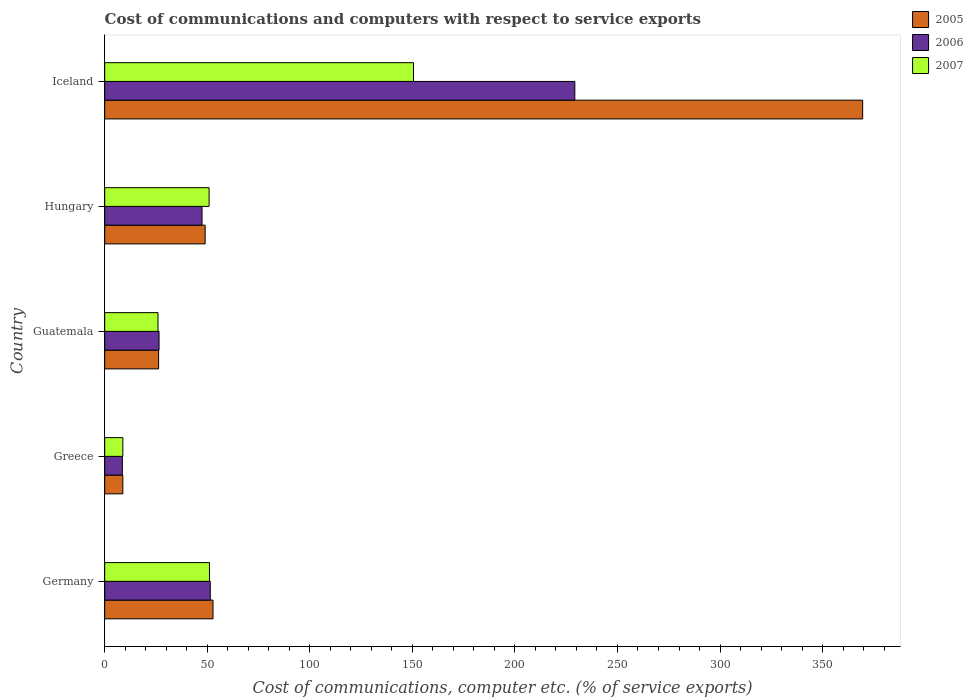How many different coloured bars are there?
Provide a succinct answer. 3. Are the number of bars per tick equal to the number of legend labels?
Offer a terse response. Yes. How many bars are there on the 3rd tick from the top?
Provide a succinct answer. 3. What is the cost of communications and computers in 2007 in Iceland?
Ensure brevity in your answer.  150.55. Across all countries, what is the maximum cost of communications and computers in 2007?
Your answer should be compact. 150.55. Across all countries, what is the minimum cost of communications and computers in 2005?
Your answer should be compact. 8.84. What is the total cost of communications and computers in 2007 in the graph?
Give a very brief answer. 287.32. What is the difference between the cost of communications and computers in 2005 in Greece and that in Iceland?
Offer a terse response. -360.7. What is the difference between the cost of communications and computers in 2006 in Guatemala and the cost of communications and computers in 2005 in Germany?
Keep it short and to the point. -26.32. What is the average cost of communications and computers in 2006 per country?
Keep it short and to the point. 72.64. What is the difference between the cost of communications and computers in 2007 and cost of communications and computers in 2006 in Iceland?
Provide a succinct answer. -78.66. In how many countries, is the cost of communications and computers in 2006 greater than 30 %?
Keep it short and to the point. 3. What is the ratio of the cost of communications and computers in 2005 in Greece to that in Guatemala?
Your response must be concise. 0.34. What is the difference between the highest and the second highest cost of communications and computers in 2007?
Provide a short and direct response. 99.49. What is the difference between the highest and the lowest cost of communications and computers in 2006?
Keep it short and to the point. 220.61. Is the sum of the cost of communications and computers in 2007 in Germany and Hungary greater than the maximum cost of communications and computers in 2006 across all countries?
Keep it short and to the point. No. What does the 1st bar from the bottom in Hungary represents?
Your answer should be very brief. 2005. How many countries are there in the graph?
Give a very brief answer. 5. What is the difference between two consecutive major ticks on the X-axis?
Make the answer very short. 50. Are the values on the major ticks of X-axis written in scientific E-notation?
Offer a terse response. No. Does the graph contain any zero values?
Provide a short and direct response. No. Does the graph contain grids?
Your answer should be compact. No. Where does the legend appear in the graph?
Your answer should be compact. Top right. How many legend labels are there?
Give a very brief answer. 3. How are the legend labels stacked?
Keep it short and to the point. Vertical. What is the title of the graph?
Your answer should be compact. Cost of communications and computers with respect to service exports. What is the label or title of the X-axis?
Provide a short and direct response. Cost of communications, computer etc. (% of service exports). What is the Cost of communications, computer etc. (% of service exports) of 2005 in Germany?
Offer a very short reply. 52.8. What is the Cost of communications, computer etc. (% of service exports) of 2006 in Germany?
Make the answer very short. 51.47. What is the Cost of communications, computer etc. (% of service exports) of 2007 in Germany?
Your answer should be very brief. 51.06. What is the Cost of communications, computer etc. (% of service exports) in 2005 in Greece?
Your answer should be compact. 8.84. What is the Cost of communications, computer etc. (% of service exports) of 2006 in Greece?
Ensure brevity in your answer.  8.6. What is the Cost of communications, computer etc. (% of service exports) of 2007 in Greece?
Offer a terse response. 8.84. What is the Cost of communications, computer etc. (% of service exports) in 2005 in Guatemala?
Your response must be concise. 26.27. What is the Cost of communications, computer etc. (% of service exports) in 2006 in Guatemala?
Provide a short and direct response. 26.49. What is the Cost of communications, computer etc. (% of service exports) of 2007 in Guatemala?
Keep it short and to the point. 25.98. What is the Cost of communications, computer etc. (% of service exports) in 2005 in Hungary?
Your answer should be compact. 48.97. What is the Cost of communications, computer etc. (% of service exports) in 2006 in Hungary?
Ensure brevity in your answer.  47.45. What is the Cost of communications, computer etc. (% of service exports) in 2007 in Hungary?
Your response must be concise. 50.89. What is the Cost of communications, computer etc. (% of service exports) of 2005 in Iceland?
Provide a succinct answer. 369.54. What is the Cost of communications, computer etc. (% of service exports) of 2006 in Iceland?
Provide a succinct answer. 229.21. What is the Cost of communications, computer etc. (% of service exports) in 2007 in Iceland?
Offer a terse response. 150.55. Across all countries, what is the maximum Cost of communications, computer etc. (% of service exports) of 2005?
Offer a very short reply. 369.54. Across all countries, what is the maximum Cost of communications, computer etc. (% of service exports) in 2006?
Your response must be concise. 229.21. Across all countries, what is the maximum Cost of communications, computer etc. (% of service exports) in 2007?
Give a very brief answer. 150.55. Across all countries, what is the minimum Cost of communications, computer etc. (% of service exports) of 2005?
Provide a short and direct response. 8.84. Across all countries, what is the minimum Cost of communications, computer etc. (% of service exports) in 2006?
Give a very brief answer. 8.6. Across all countries, what is the minimum Cost of communications, computer etc. (% of service exports) of 2007?
Give a very brief answer. 8.84. What is the total Cost of communications, computer etc. (% of service exports) of 2005 in the graph?
Offer a terse response. 506.42. What is the total Cost of communications, computer etc. (% of service exports) of 2006 in the graph?
Your answer should be very brief. 363.22. What is the total Cost of communications, computer etc. (% of service exports) in 2007 in the graph?
Provide a short and direct response. 287.32. What is the difference between the Cost of communications, computer etc. (% of service exports) of 2005 in Germany and that in Greece?
Offer a very short reply. 43.96. What is the difference between the Cost of communications, computer etc. (% of service exports) in 2006 in Germany and that in Greece?
Make the answer very short. 42.87. What is the difference between the Cost of communications, computer etc. (% of service exports) in 2007 in Germany and that in Greece?
Ensure brevity in your answer.  42.22. What is the difference between the Cost of communications, computer etc. (% of service exports) of 2005 in Germany and that in Guatemala?
Your answer should be compact. 26.54. What is the difference between the Cost of communications, computer etc. (% of service exports) of 2006 in Germany and that in Guatemala?
Your answer should be compact. 24.98. What is the difference between the Cost of communications, computer etc. (% of service exports) in 2007 in Germany and that in Guatemala?
Offer a very short reply. 25.09. What is the difference between the Cost of communications, computer etc. (% of service exports) in 2005 in Germany and that in Hungary?
Give a very brief answer. 3.84. What is the difference between the Cost of communications, computer etc. (% of service exports) of 2006 in Germany and that in Hungary?
Provide a short and direct response. 4.01. What is the difference between the Cost of communications, computer etc. (% of service exports) in 2007 in Germany and that in Hungary?
Give a very brief answer. 0.17. What is the difference between the Cost of communications, computer etc. (% of service exports) in 2005 in Germany and that in Iceland?
Your answer should be compact. -316.74. What is the difference between the Cost of communications, computer etc. (% of service exports) in 2006 in Germany and that in Iceland?
Ensure brevity in your answer.  -177.74. What is the difference between the Cost of communications, computer etc. (% of service exports) in 2007 in Germany and that in Iceland?
Provide a succinct answer. -99.49. What is the difference between the Cost of communications, computer etc. (% of service exports) of 2005 in Greece and that in Guatemala?
Offer a very short reply. -17.42. What is the difference between the Cost of communications, computer etc. (% of service exports) of 2006 in Greece and that in Guatemala?
Keep it short and to the point. -17.89. What is the difference between the Cost of communications, computer etc. (% of service exports) in 2007 in Greece and that in Guatemala?
Give a very brief answer. -17.13. What is the difference between the Cost of communications, computer etc. (% of service exports) in 2005 in Greece and that in Hungary?
Offer a very short reply. -40.13. What is the difference between the Cost of communications, computer etc. (% of service exports) of 2006 in Greece and that in Hungary?
Keep it short and to the point. -38.86. What is the difference between the Cost of communications, computer etc. (% of service exports) in 2007 in Greece and that in Hungary?
Keep it short and to the point. -42.05. What is the difference between the Cost of communications, computer etc. (% of service exports) of 2005 in Greece and that in Iceland?
Make the answer very short. -360.7. What is the difference between the Cost of communications, computer etc. (% of service exports) in 2006 in Greece and that in Iceland?
Your response must be concise. -220.61. What is the difference between the Cost of communications, computer etc. (% of service exports) of 2007 in Greece and that in Iceland?
Ensure brevity in your answer.  -141.71. What is the difference between the Cost of communications, computer etc. (% of service exports) of 2005 in Guatemala and that in Hungary?
Provide a short and direct response. -22.7. What is the difference between the Cost of communications, computer etc. (% of service exports) of 2006 in Guatemala and that in Hungary?
Offer a very short reply. -20.97. What is the difference between the Cost of communications, computer etc. (% of service exports) in 2007 in Guatemala and that in Hungary?
Your answer should be very brief. -24.91. What is the difference between the Cost of communications, computer etc. (% of service exports) of 2005 in Guatemala and that in Iceland?
Offer a terse response. -343.28. What is the difference between the Cost of communications, computer etc. (% of service exports) of 2006 in Guatemala and that in Iceland?
Make the answer very short. -202.72. What is the difference between the Cost of communications, computer etc. (% of service exports) of 2007 in Guatemala and that in Iceland?
Offer a very short reply. -124.58. What is the difference between the Cost of communications, computer etc. (% of service exports) of 2005 in Hungary and that in Iceland?
Make the answer very short. -320.58. What is the difference between the Cost of communications, computer etc. (% of service exports) of 2006 in Hungary and that in Iceland?
Your answer should be compact. -181.76. What is the difference between the Cost of communications, computer etc. (% of service exports) of 2007 in Hungary and that in Iceland?
Provide a succinct answer. -99.66. What is the difference between the Cost of communications, computer etc. (% of service exports) in 2005 in Germany and the Cost of communications, computer etc. (% of service exports) in 2006 in Greece?
Give a very brief answer. 44.2. What is the difference between the Cost of communications, computer etc. (% of service exports) of 2005 in Germany and the Cost of communications, computer etc. (% of service exports) of 2007 in Greece?
Provide a succinct answer. 43.96. What is the difference between the Cost of communications, computer etc. (% of service exports) in 2006 in Germany and the Cost of communications, computer etc. (% of service exports) in 2007 in Greece?
Give a very brief answer. 42.63. What is the difference between the Cost of communications, computer etc. (% of service exports) of 2005 in Germany and the Cost of communications, computer etc. (% of service exports) of 2006 in Guatemala?
Provide a succinct answer. 26.32. What is the difference between the Cost of communications, computer etc. (% of service exports) in 2005 in Germany and the Cost of communications, computer etc. (% of service exports) in 2007 in Guatemala?
Ensure brevity in your answer.  26.83. What is the difference between the Cost of communications, computer etc. (% of service exports) of 2006 in Germany and the Cost of communications, computer etc. (% of service exports) of 2007 in Guatemala?
Make the answer very short. 25.49. What is the difference between the Cost of communications, computer etc. (% of service exports) of 2005 in Germany and the Cost of communications, computer etc. (% of service exports) of 2006 in Hungary?
Keep it short and to the point. 5.35. What is the difference between the Cost of communications, computer etc. (% of service exports) of 2005 in Germany and the Cost of communications, computer etc. (% of service exports) of 2007 in Hungary?
Give a very brief answer. 1.91. What is the difference between the Cost of communications, computer etc. (% of service exports) of 2006 in Germany and the Cost of communications, computer etc. (% of service exports) of 2007 in Hungary?
Provide a short and direct response. 0.58. What is the difference between the Cost of communications, computer etc. (% of service exports) in 2005 in Germany and the Cost of communications, computer etc. (% of service exports) in 2006 in Iceland?
Give a very brief answer. -176.41. What is the difference between the Cost of communications, computer etc. (% of service exports) in 2005 in Germany and the Cost of communications, computer etc. (% of service exports) in 2007 in Iceland?
Keep it short and to the point. -97.75. What is the difference between the Cost of communications, computer etc. (% of service exports) of 2006 in Germany and the Cost of communications, computer etc. (% of service exports) of 2007 in Iceland?
Ensure brevity in your answer.  -99.09. What is the difference between the Cost of communications, computer etc. (% of service exports) of 2005 in Greece and the Cost of communications, computer etc. (% of service exports) of 2006 in Guatemala?
Give a very brief answer. -17.65. What is the difference between the Cost of communications, computer etc. (% of service exports) in 2005 in Greece and the Cost of communications, computer etc. (% of service exports) in 2007 in Guatemala?
Keep it short and to the point. -17.14. What is the difference between the Cost of communications, computer etc. (% of service exports) of 2006 in Greece and the Cost of communications, computer etc. (% of service exports) of 2007 in Guatemala?
Your answer should be compact. -17.38. What is the difference between the Cost of communications, computer etc. (% of service exports) of 2005 in Greece and the Cost of communications, computer etc. (% of service exports) of 2006 in Hungary?
Provide a succinct answer. -38.61. What is the difference between the Cost of communications, computer etc. (% of service exports) of 2005 in Greece and the Cost of communications, computer etc. (% of service exports) of 2007 in Hungary?
Your answer should be very brief. -42.05. What is the difference between the Cost of communications, computer etc. (% of service exports) in 2006 in Greece and the Cost of communications, computer etc. (% of service exports) in 2007 in Hungary?
Make the answer very short. -42.29. What is the difference between the Cost of communications, computer etc. (% of service exports) of 2005 in Greece and the Cost of communications, computer etc. (% of service exports) of 2006 in Iceland?
Your answer should be very brief. -220.37. What is the difference between the Cost of communications, computer etc. (% of service exports) in 2005 in Greece and the Cost of communications, computer etc. (% of service exports) in 2007 in Iceland?
Your answer should be very brief. -141.71. What is the difference between the Cost of communications, computer etc. (% of service exports) of 2006 in Greece and the Cost of communications, computer etc. (% of service exports) of 2007 in Iceland?
Give a very brief answer. -141.96. What is the difference between the Cost of communications, computer etc. (% of service exports) of 2005 in Guatemala and the Cost of communications, computer etc. (% of service exports) of 2006 in Hungary?
Make the answer very short. -21.19. What is the difference between the Cost of communications, computer etc. (% of service exports) of 2005 in Guatemala and the Cost of communications, computer etc. (% of service exports) of 2007 in Hungary?
Your answer should be very brief. -24.62. What is the difference between the Cost of communications, computer etc. (% of service exports) in 2006 in Guatemala and the Cost of communications, computer etc. (% of service exports) in 2007 in Hungary?
Provide a short and direct response. -24.4. What is the difference between the Cost of communications, computer etc. (% of service exports) in 2005 in Guatemala and the Cost of communications, computer etc. (% of service exports) in 2006 in Iceland?
Provide a succinct answer. -202.95. What is the difference between the Cost of communications, computer etc. (% of service exports) in 2005 in Guatemala and the Cost of communications, computer etc. (% of service exports) in 2007 in Iceland?
Your response must be concise. -124.29. What is the difference between the Cost of communications, computer etc. (% of service exports) of 2006 in Guatemala and the Cost of communications, computer etc. (% of service exports) of 2007 in Iceland?
Keep it short and to the point. -124.07. What is the difference between the Cost of communications, computer etc. (% of service exports) of 2005 in Hungary and the Cost of communications, computer etc. (% of service exports) of 2006 in Iceland?
Your answer should be compact. -180.25. What is the difference between the Cost of communications, computer etc. (% of service exports) in 2005 in Hungary and the Cost of communications, computer etc. (% of service exports) in 2007 in Iceland?
Your answer should be very brief. -101.59. What is the difference between the Cost of communications, computer etc. (% of service exports) of 2006 in Hungary and the Cost of communications, computer etc. (% of service exports) of 2007 in Iceland?
Offer a terse response. -103.1. What is the average Cost of communications, computer etc. (% of service exports) of 2005 per country?
Ensure brevity in your answer.  101.28. What is the average Cost of communications, computer etc. (% of service exports) in 2006 per country?
Offer a terse response. 72.64. What is the average Cost of communications, computer etc. (% of service exports) of 2007 per country?
Ensure brevity in your answer.  57.46. What is the difference between the Cost of communications, computer etc. (% of service exports) in 2005 and Cost of communications, computer etc. (% of service exports) in 2006 in Germany?
Provide a succinct answer. 1.33. What is the difference between the Cost of communications, computer etc. (% of service exports) of 2005 and Cost of communications, computer etc. (% of service exports) of 2007 in Germany?
Offer a very short reply. 1.74. What is the difference between the Cost of communications, computer etc. (% of service exports) of 2006 and Cost of communications, computer etc. (% of service exports) of 2007 in Germany?
Keep it short and to the point. 0.4. What is the difference between the Cost of communications, computer etc. (% of service exports) of 2005 and Cost of communications, computer etc. (% of service exports) of 2006 in Greece?
Provide a succinct answer. 0.24. What is the difference between the Cost of communications, computer etc. (% of service exports) of 2005 and Cost of communications, computer etc. (% of service exports) of 2007 in Greece?
Provide a short and direct response. -0. What is the difference between the Cost of communications, computer etc. (% of service exports) of 2006 and Cost of communications, computer etc. (% of service exports) of 2007 in Greece?
Your answer should be very brief. -0.24. What is the difference between the Cost of communications, computer etc. (% of service exports) of 2005 and Cost of communications, computer etc. (% of service exports) of 2006 in Guatemala?
Your answer should be compact. -0.22. What is the difference between the Cost of communications, computer etc. (% of service exports) of 2005 and Cost of communications, computer etc. (% of service exports) of 2007 in Guatemala?
Ensure brevity in your answer.  0.29. What is the difference between the Cost of communications, computer etc. (% of service exports) of 2006 and Cost of communications, computer etc. (% of service exports) of 2007 in Guatemala?
Your answer should be very brief. 0.51. What is the difference between the Cost of communications, computer etc. (% of service exports) of 2005 and Cost of communications, computer etc. (% of service exports) of 2006 in Hungary?
Your answer should be compact. 1.51. What is the difference between the Cost of communications, computer etc. (% of service exports) of 2005 and Cost of communications, computer etc. (% of service exports) of 2007 in Hungary?
Provide a succinct answer. -1.92. What is the difference between the Cost of communications, computer etc. (% of service exports) of 2006 and Cost of communications, computer etc. (% of service exports) of 2007 in Hungary?
Provide a short and direct response. -3.44. What is the difference between the Cost of communications, computer etc. (% of service exports) of 2005 and Cost of communications, computer etc. (% of service exports) of 2006 in Iceland?
Your answer should be very brief. 140.33. What is the difference between the Cost of communications, computer etc. (% of service exports) of 2005 and Cost of communications, computer etc. (% of service exports) of 2007 in Iceland?
Make the answer very short. 218.99. What is the difference between the Cost of communications, computer etc. (% of service exports) of 2006 and Cost of communications, computer etc. (% of service exports) of 2007 in Iceland?
Your answer should be very brief. 78.66. What is the ratio of the Cost of communications, computer etc. (% of service exports) in 2005 in Germany to that in Greece?
Keep it short and to the point. 5.97. What is the ratio of the Cost of communications, computer etc. (% of service exports) in 2006 in Germany to that in Greece?
Your answer should be compact. 5.99. What is the ratio of the Cost of communications, computer etc. (% of service exports) in 2007 in Germany to that in Greece?
Your response must be concise. 5.78. What is the ratio of the Cost of communications, computer etc. (% of service exports) of 2005 in Germany to that in Guatemala?
Offer a very short reply. 2.01. What is the ratio of the Cost of communications, computer etc. (% of service exports) in 2006 in Germany to that in Guatemala?
Give a very brief answer. 1.94. What is the ratio of the Cost of communications, computer etc. (% of service exports) in 2007 in Germany to that in Guatemala?
Your answer should be very brief. 1.97. What is the ratio of the Cost of communications, computer etc. (% of service exports) of 2005 in Germany to that in Hungary?
Provide a short and direct response. 1.08. What is the ratio of the Cost of communications, computer etc. (% of service exports) of 2006 in Germany to that in Hungary?
Your response must be concise. 1.08. What is the ratio of the Cost of communications, computer etc. (% of service exports) of 2007 in Germany to that in Hungary?
Keep it short and to the point. 1. What is the ratio of the Cost of communications, computer etc. (% of service exports) in 2005 in Germany to that in Iceland?
Provide a short and direct response. 0.14. What is the ratio of the Cost of communications, computer etc. (% of service exports) of 2006 in Germany to that in Iceland?
Make the answer very short. 0.22. What is the ratio of the Cost of communications, computer etc. (% of service exports) of 2007 in Germany to that in Iceland?
Your answer should be very brief. 0.34. What is the ratio of the Cost of communications, computer etc. (% of service exports) in 2005 in Greece to that in Guatemala?
Give a very brief answer. 0.34. What is the ratio of the Cost of communications, computer etc. (% of service exports) of 2006 in Greece to that in Guatemala?
Offer a very short reply. 0.32. What is the ratio of the Cost of communications, computer etc. (% of service exports) of 2007 in Greece to that in Guatemala?
Ensure brevity in your answer.  0.34. What is the ratio of the Cost of communications, computer etc. (% of service exports) in 2005 in Greece to that in Hungary?
Keep it short and to the point. 0.18. What is the ratio of the Cost of communications, computer etc. (% of service exports) of 2006 in Greece to that in Hungary?
Provide a succinct answer. 0.18. What is the ratio of the Cost of communications, computer etc. (% of service exports) of 2007 in Greece to that in Hungary?
Offer a very short reply. 0.17. What is the ratio of the Cost of communications, computer etc. (% of service exports) in 2005 in Greece to that in Iceland?
Ensure brevity in your answer.  0.02. What is the ratio of the Cost of communications, computer etc. (% of service exports) of 2006 in Greece to that in Iceland?
Provide a short and direct response. 0.04. What is the ratio of the Cost of communications, computer etc. (% of service exports) in 2007 in Greece to that in Iceland?
Offer a terse response. 0.06. What is the ratio of the Cost of communications, computer etc. (% of service exports) in 2005 in Guatemala to that in Hungary?
Keep it short and to the point. 0.54. What is the ratio of the Cost of communications, computer etc. (% of service exports) in 2006 in Guatemala to that in Hungary?
Make the answer very short. 0.56. What is the ratio of the Cost of communications, computer etc. (% of service exports) in 2007 in Guatemala to that in Hungary?
Make the answer very short. 0.51. What is the ratio of the Cost of communications, computer etc. (% of service exports) in 2005 in Guatemala to that in Iceland?
Offer a very short reply. 0.07. What is the ratio of the Cost of communications, computer etc. (% of service exports) of 2006 in Guatemala to that in Iceland?
Make the answer very short. 0.12. What is the ratio of the Cost of communications, computer etc. (% of service exports) in 2007 in Guatemala to that in Iceland?
Provide a succinct answer. 0.17. What is the ratio of the Cost of communications, computer etc. (% of service exports) in 2005 in Hungary to that in Iceland?
Your answer should be very brief. 0.13. What is the ratio of the Cost of communications, computer etc. (% of service exports) in 2006 in Hungary to that in Iceland?
Give a very brief answer. 0.21. What is the ratio of the Cost of communications, computer etc. (% of service exports) in 2007 in Hungary to that in Iceland?
Ensure brevity in your answer.  0.34. What is the difference between the highest and the second highest Cost of communications, computer etc. (% of service exports) in 2005?
Make the answer very short. 316.74. What is the difference between the highest and the second highest Cost of communications, computer etc. (% of service exports) in 2006?
Your answer should be compact. 177.74. What is the difference between the highest and the second highest Cost of communications, computer etc. (% of service exports) of 2007?
Keep it short and to the point. 99.49. What is the difference between the highest and the lowest Cost of communications, computer etc. (% of service exports) in 2005?
Your answer should be very brief. 360.7. What is the difference between the highest and the lowest Cost of communications, computer etc. (% of service exports) of 2006?
Make the answer very short. 220.61. What is the difference between the highest and the lowest Cost of communications, computer etc. (% of service exports) in 2007?
Provide a short and direct response. 141.71. 